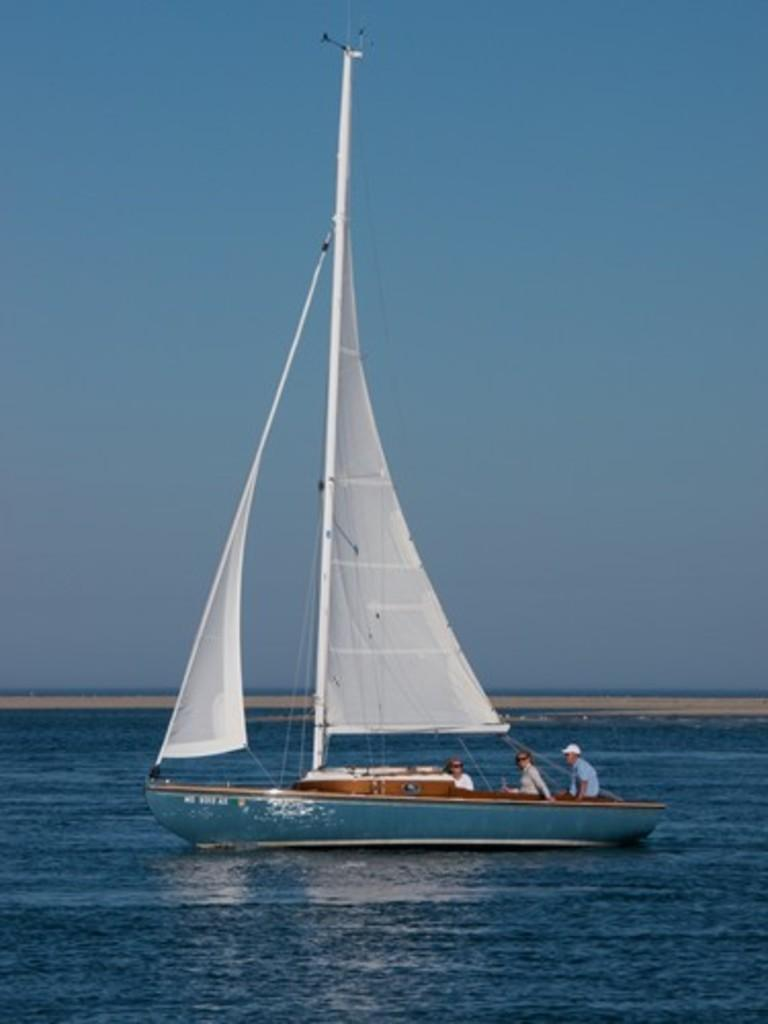What is the main subject of the image? There is a boat in the image. What color is the water surrounding the boat? The water is blue in color. What feature can be seen on the boat? There is a pole on the boat. What type of surface is visible in the background? There is a sand surface visible in the background. What else can be seen in the background? The sky is visible in the background. Does the boat have a friend in the image? There is no indication of a friend for the boat in the image. Can you tell me how many fields are present in the image? There are no fields visible in the image; it features a boat on water with a sand and sky background. 